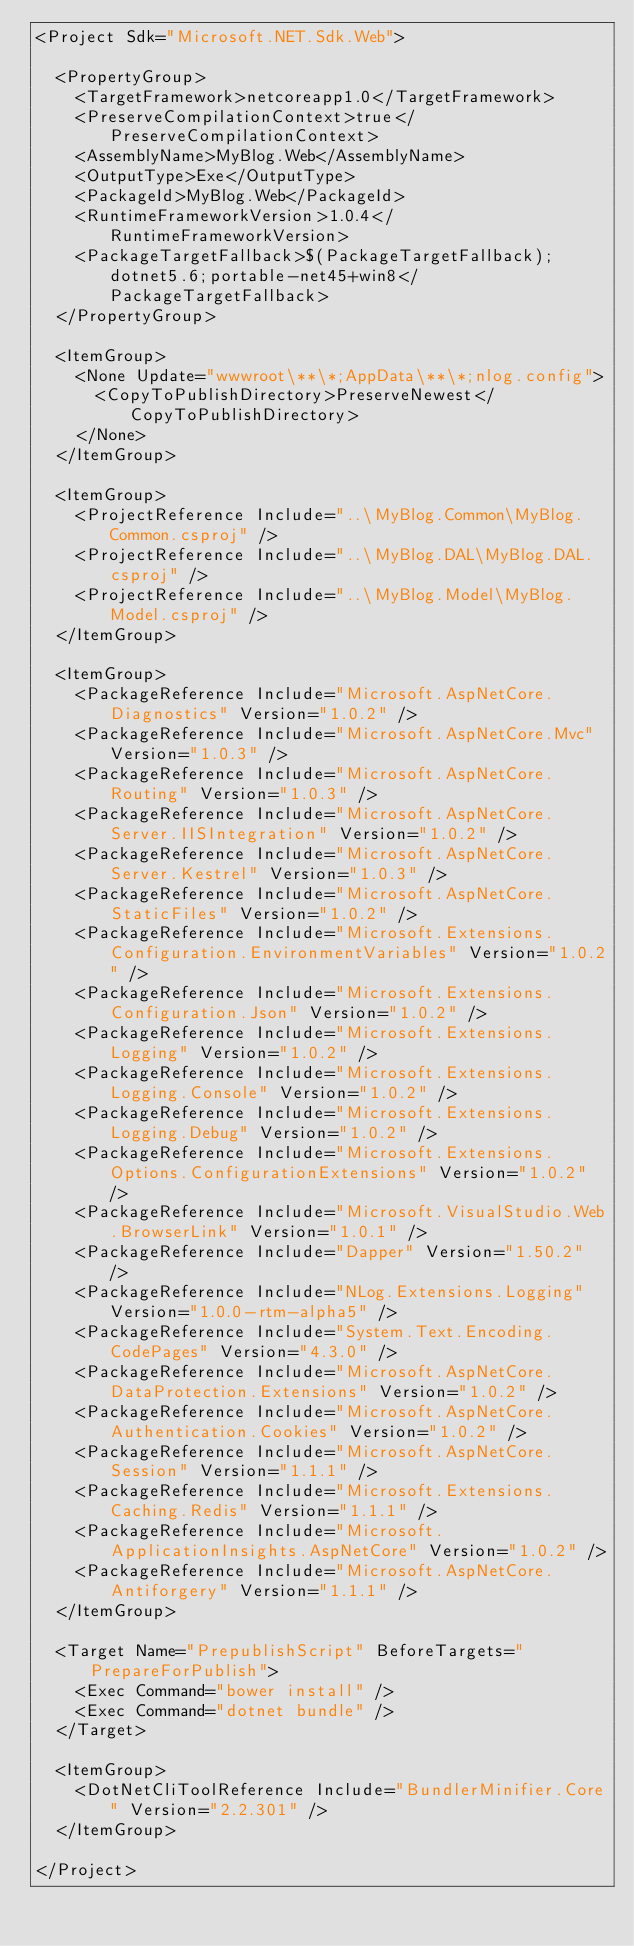<code> <loc_0><loc_0><loc_500><loc_500><_XML_><Project Sdk="Microsoft.NET.Sdk.Web">

  <PropertyGroup>
    <TargetFramework>netcoreapp1.0</TargetFramework>
    <PreserveCompilationContext>true</PreserveCompilationContext>
    <AssemblyName>MyBlog.Web</AssemblyName>
    <OutputType>Exe</OutputType>
    <PackageId>MyBlog.Web</PackageId>
    <RuntimeFrameworkVersion>1.0.4</RuntimeFrameworkVersion>
    <PackageTargetFallback>$(PackageTargetFallback);dotnet5.6;portable-net45+win8</PackageTargetFallback>
  </PropertyGroup>

  <ItemGroup>
    <None Update="wwwroot\**\*;AppData\**\*;nlog.config">
      <CopyToPublishDirectory>PreserveNewest</CopyToPublishDirectory>
    </None>
  </ItemGroup>

  <ItemGroup>
    <ProjectReference Include="..\MyBlog.Common\MyBlog.Common.csproj" />
    <ProjectReference Include="..\MyBlog.DAL\MyBlog.DAL.csproj" />
    <ProjectReference Include="..\MyBlog.Model\MyBlog.Model.csproj" />
  </ItemGroup>

  <ItemGroup>
    <PackageReference Include="Microsoft.AspNetCore.Diagnostics" Version="1.0.2" />
    <PackageReference Include="Microsoft.AspNetCore.Mvc" Version="1.0.3" />
    <PackageReference Include="Microsoft.AspNetCore.Routing" Version="1.0.3" />
    <PackageReference Include="Microsoft.AspNetCore.Server.IISIntegration" Version="1.0.2" />
    <PackageReference Include="Microsoft.AspNetCore.Server.Kestrel" Version="1.0.3" />
    <PackageReference Include="Microsoft.AspNetCore.StaticFiles" Version="1.0.2" />
    <PackageReference Include="Microsoft.Extensions.Configuration.EnvironmentVariables" Version="1.0.2" />
    <PackageReference Include="Microsoft.Extensions.Configuration.Json" Version="1.0.2" />
    <PackageReference Include="Microsoft.Extensions.Logging" Version="1.0.2" />
    <PackageReference Include="Microsoft.Extensions.Logging.Console" Version="1.0.2" />
    <PackageReference Include="Microsoft.Extensions.Logging.Debug" Version="1.0.2" />
    <PackageReference Include="Microsoft.Extensions.Options.ConfigurationExtensions" Version="1.0.2" />
    <PackageReference Include="Microsoft.VisualStudio.Web.BrowserLink" Version="1.0.1" />
    <PackageReference Include="Dapper" Version="1.50.2" />
    <PackageReference Include="NLog.Extensions.Logging" Version="1.0.0-rtm-alpha5" />
    <PackageReference Include="System.Text.Encoding.CodePages" Version="4.3.0" />
    <PackageReference Include="Microsoft.AspNetCore.DataProtection.Extensions" Version="1.0.2" />
    <PackageReference Include="Microsoft.AspNetCore.Authentication.Cookies" Version="1.0.2" />
    <PackageReference Include="Microsoft.AspNetCore.Session" Version="1.1.1" />
    <PackageReference Include="Microsoft.Extensions.Caching.Redis" Version="1.1.1" />
    <PackageReference Include="Microsoft.ApplicationInsights.AspNetCore" Version="1.0.2" />
    <PackageReference Include="Microsoft.AspNetCore.Antiforgery" Version="1.1.1" />
  </ItemGroup>

  <Target Name="PrepublishScript" BeforeTargets="PrepareForPublish">
    <Exec Command="bower install" />
    <Exec Command="dotnet bundle" />
  </Target>

  <ItemGroup>
    <DotNetCliToolReference Include="BundlerMinifier.Core" Version="2.2.301" />
  </ItemGroup>

</Project>
</code> 